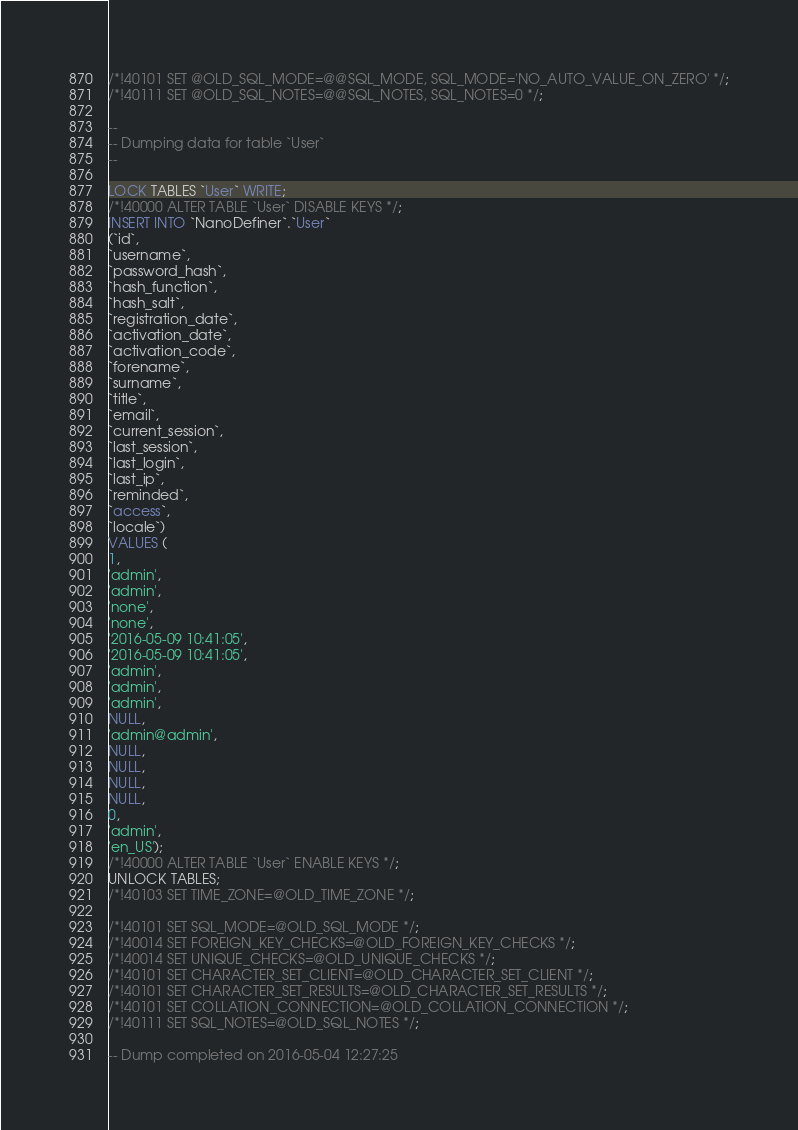<code> <loc_0><loc_0><loc_500><loc_500><_SQL_>/*!40101 SET @OLD_SQL_MODE=@@SQL_MODE, SQL_MODE='NO_AUTO_VALUE_ON_ZERO' */;
/*!40111 SET @OLD_SQL_NOTES=@@SQL_NOTES, SQL_NOTES=0 */;

--
-- Dumping data for table `User`
--

LOCK TABLES `User` WRITE;
/*!40000 ALTER TABLE `User` DISABLE KEYS */;
INSERT INTO `NanoDefiner`.`User`
(`id`,
`username`,
`password_hash`,
`hash_function`,
`hash_salt`,
`registration_date`,
`activation_date`,
`activation_code`,
`forename`,
`surname`,
`title`,
`email`,
`current_session`,
`last_session`,
`last_login`,
`last_ip`,
`reminded`,
`access`,
`locale`)
VALUES (
1,
'admin',
'admin',
'none',
'none',
'2016-05-09 10:41:05',
'2016-05-09 10:41:05',
'admin',
'admin',
'admin',
NULL,
'admin@admin',
NULL,
NULL,
NULL,
NULL,
0,
'admin',
'en_US');
/*!40000 ALTER TABLE `User` ENABLE KEYS */;
UNLOCK TABLES;
/*!40103 SET TIME_ZONE=@OLD_TIME_ZONE */;

/*!40101 SET SQL_MODE=@OLD_SQL_MODE */;
/*!40014 SET FOREIGN_KEY_CHECKS=@OLD_FOREIGN_KEY_CHECKS */;
/*!40014 SET UNIQUE_CHECKS=@OLD_UNIQUE_CHECKS */;
/*!40101 SET CHARACTER_SET_CLIENT=@OLD_CHARACTER_SET_CLIENT */;
/*!40101 SET CHARACTER_SET_RESULTS=@OLD_CHARACTER_SET_RESULTS */;
/*!40101 SET COLLATION_CONNECTION=@OLD_COLLATION_CONNECTION */;
/*!40111 SET SQL_NOTES=@OLD_SQL_NOTES */;

-- Dump completed on 2016-05-04 12:27:25
</code> 